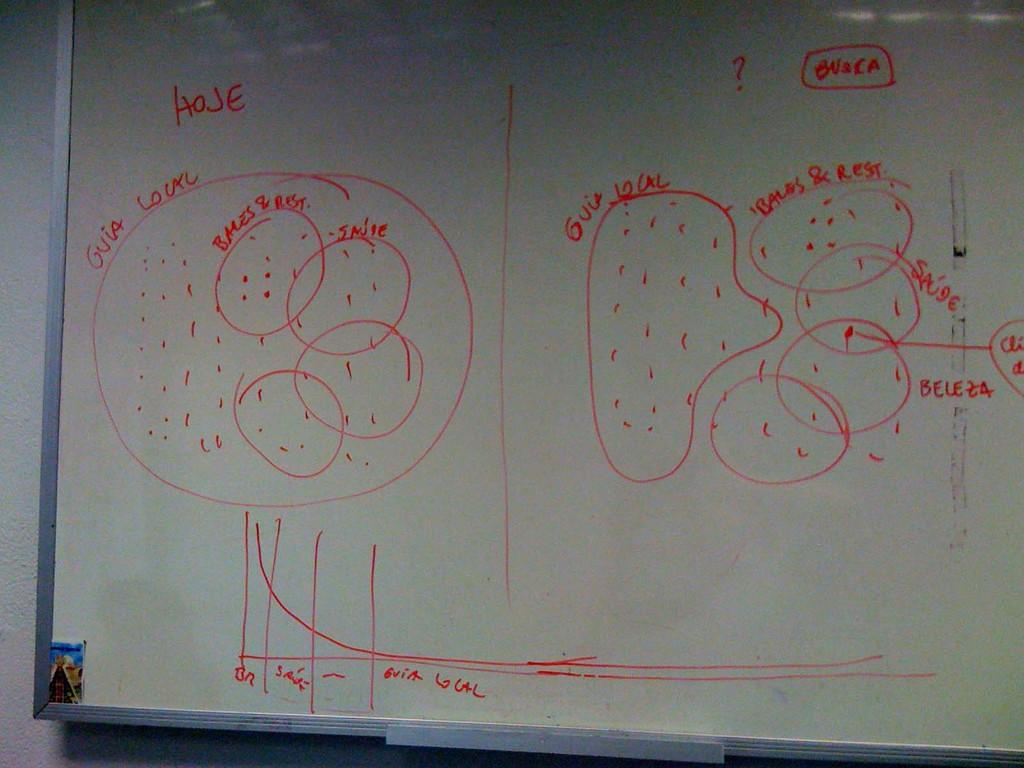Provide a one-sentence caption for the provided image. a drawing on a blackboard describing Gvia Lourc. 